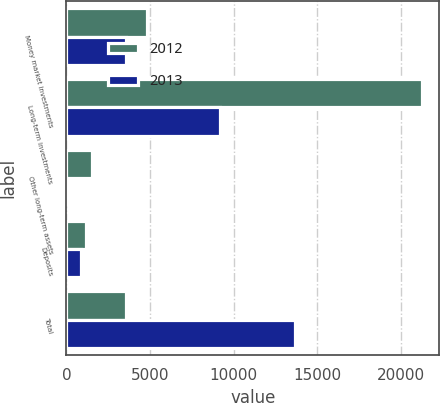Convert chart. <chart><loc_0><loc_0><loc_500><loc_500><stacked_bar_chart><ecel><fcel>Money market investments<fcel>Long-term investments<fcel>Other long-term assets<fcel>Deposits<fcel>Total<nl><fcel>2012<fcel>4827<fcel>21242<fcel>1522<fcel>1174<fcel>3553<nl><fcel>2013<fcel>3553<fcel>9195<fcel>0<fcel>898<fcel>13646<nl></chart> 